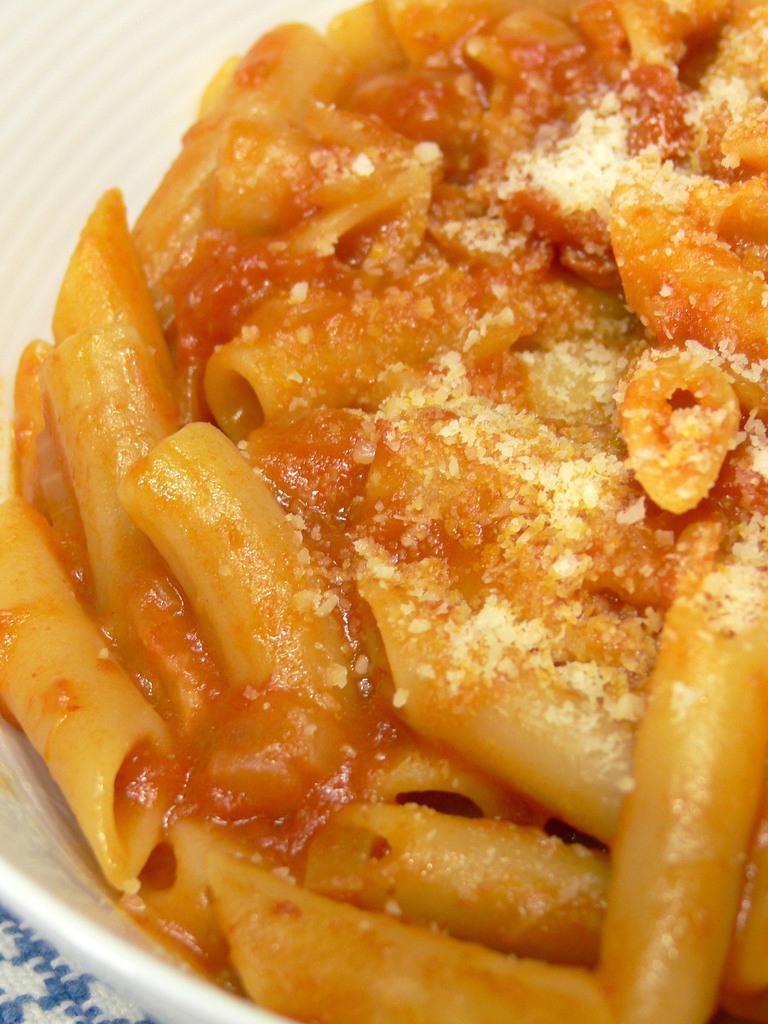Can you describe this image briefly? In this image I can see the food in the bowl and the food is in brown and cream color and the bowl is in white color. 